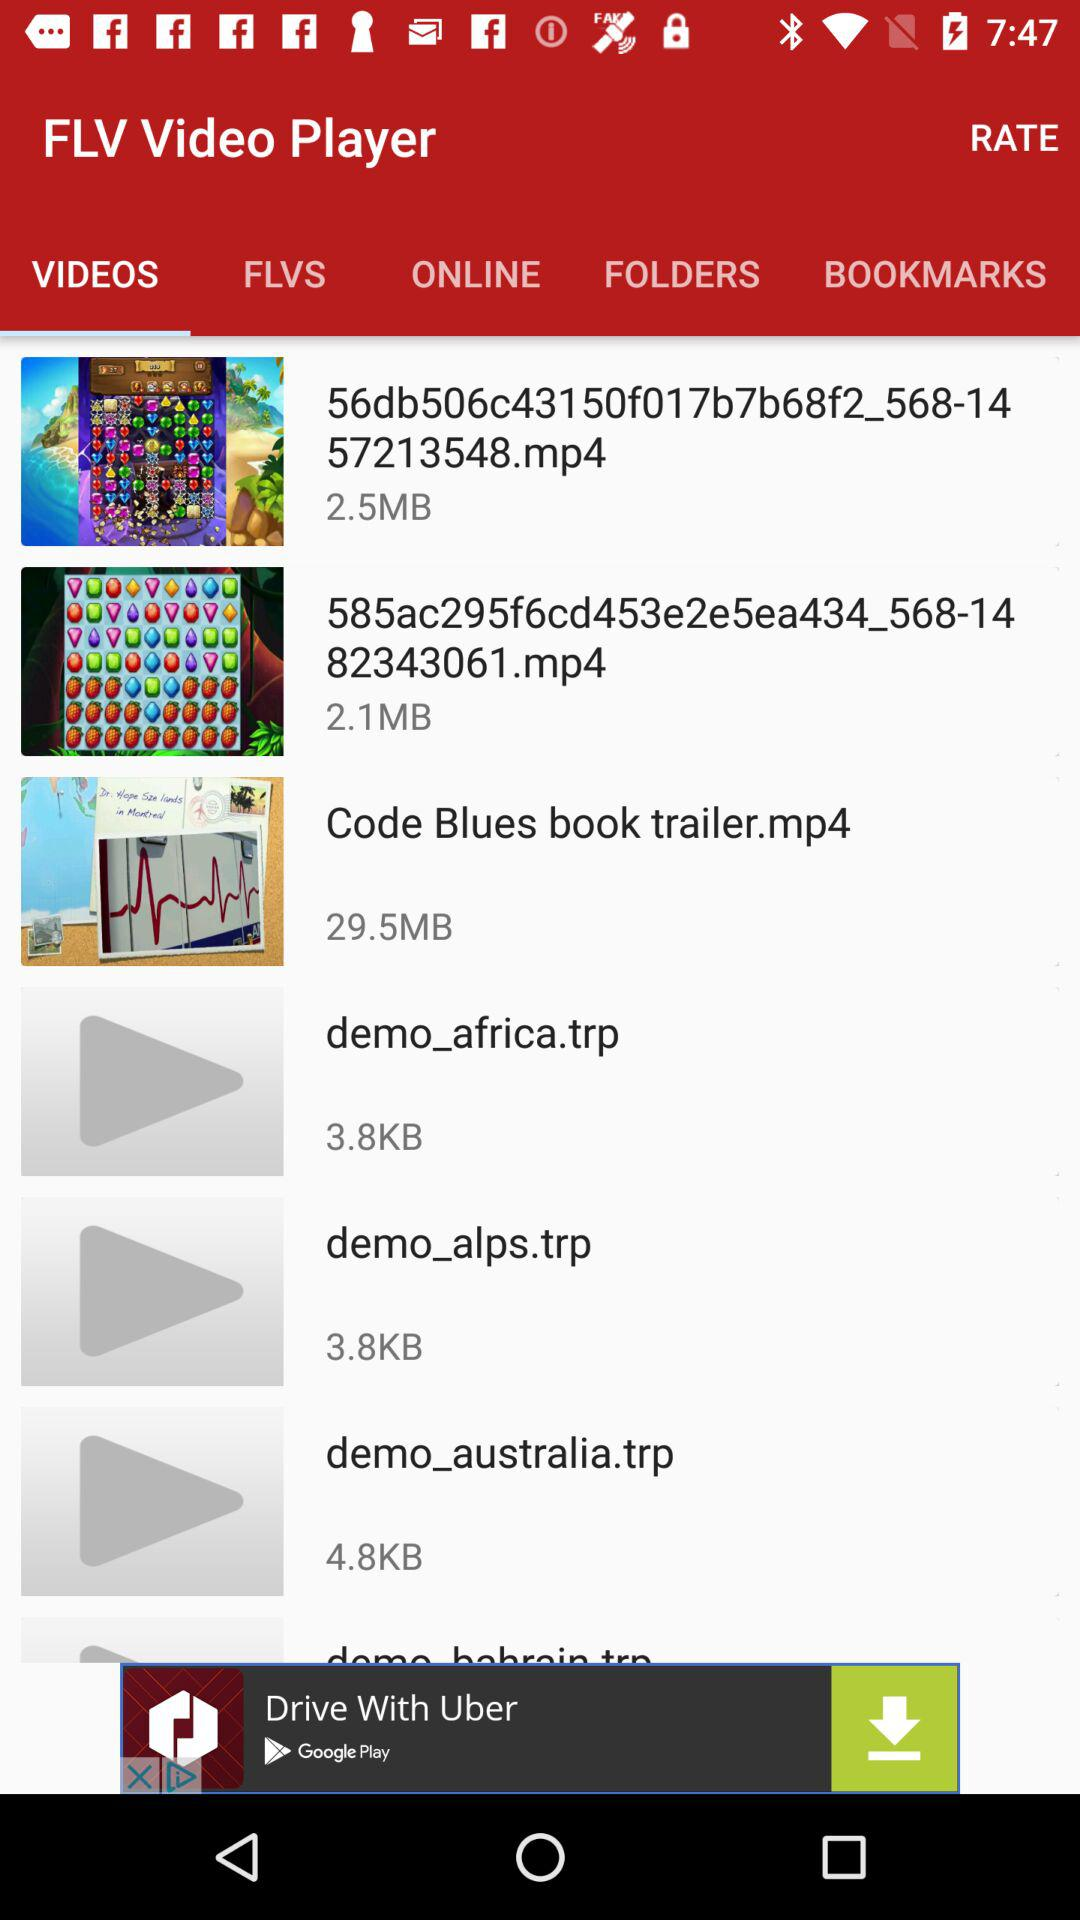What is the name of the application? The name of the application is "FLV Video Player". 